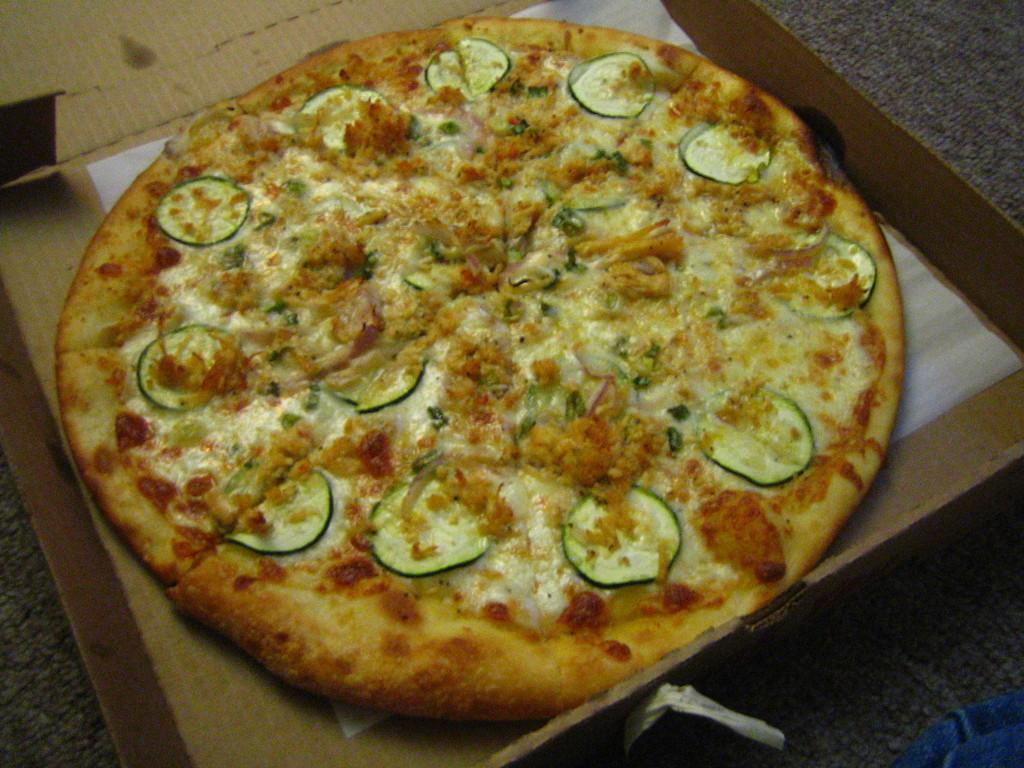Could you give a brief overview of what you see in this image? In this image we can see a pizza, carton box, and a paper. 